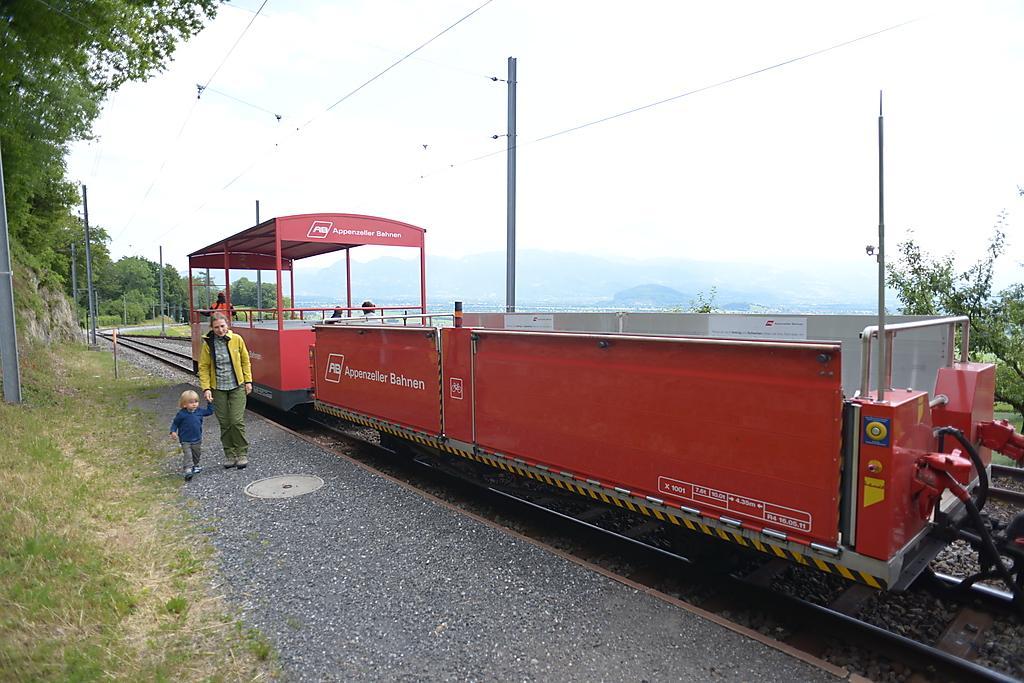In one or two sentences, can you explain what this image depicts? This is the picture of a train on the train track which is red in color and to the side there is a kid and a person and around there are some poles,trees and plants. 